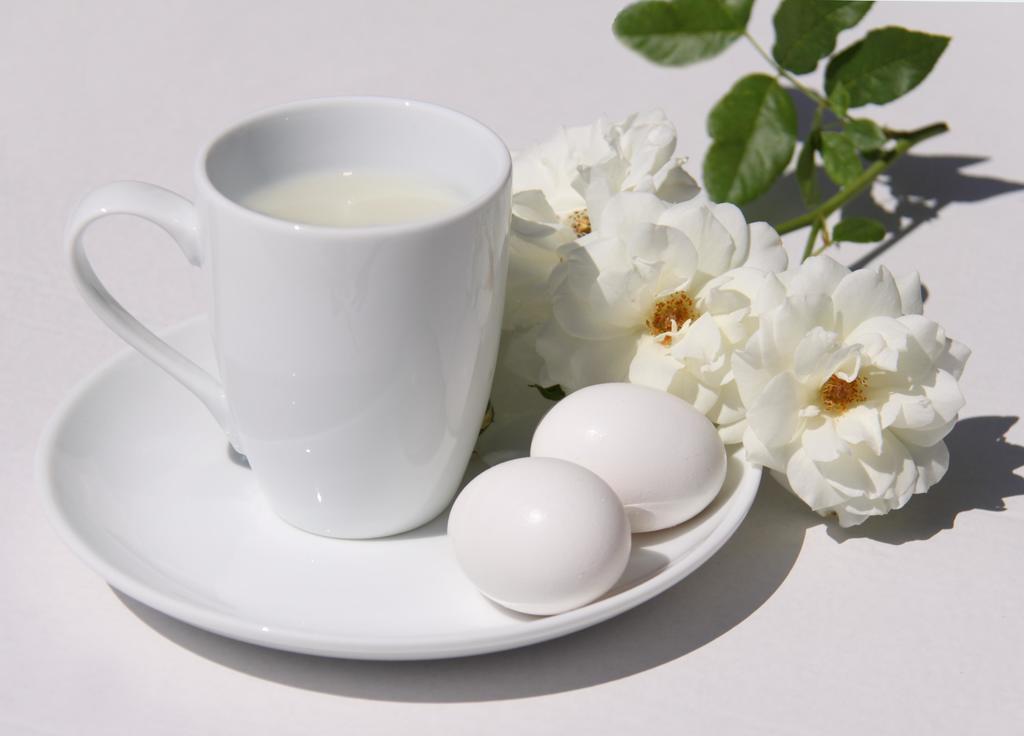In one or two sentences, can you explain what this image depicts? In this image we can see a cup containing a drink in it is placed in a plate on which two eggs group of flowers with group of leaves on its stems are placed. 